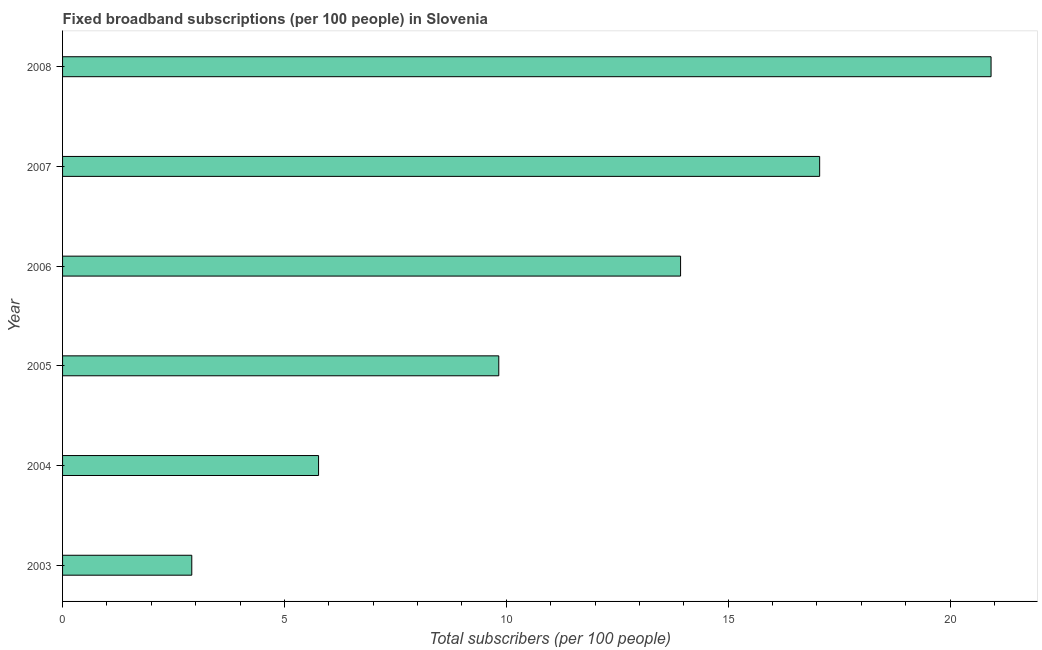Does the graph contain any zero values?
Give a very brief answer. No. Does the graph contain grids?
Provide a short and direct response. No. What is the title of the graph?
Your response must be concise. Fixed broadband subscriptions (per 100 people) in Slovenia. What is the label or title of the X-axis?
Offer a terse response. Total subscribers (per 100 people). What is the total number of fixed broadband subscriptions in 2004?
Make the answer very short. 5.77. Across all years, what is the maximum total number of fixed broadband subscriptions?
Your answer should be compact. 20.92. Across all years, what is the minimum total number of fixed broadband subscriptions?
Ensure brevity in your answer.  2.91. In which year was the total number of fixed broadband subscriptions minimum?
Your answer should be compact. 2003. What is the sum of the total number of fixed broadband subscriptions?
Give a very brief answer. 70.43. What is the difference between the total number of fixed broadband subscriptions in 2003 and 2008?
Provide a short and direct response. -18.01. What is the average total number of fixed broadband subscriptions per year?
Offer a very short reply. 11.74. What is the median total number of fixed broadband subscriptions?
Your answer should be very brief. 11.88. In how many years, is the total number of fixed broadband subscriptions greater than 6 ?
Keep it short and to the point. 4. Do a majority of the years between 2006 and 2007 (inclusive) have total number of fixed broadband subscriptions greater than 10 ?
Give a very brief answer. Yes. What is the ratio of the total number of fixed broadband subscriptions in 2004 to that in 2005?
Your response must be concise. 0.59. Is the total number of fixed broadband subscriptions in 2005 less than that in 2008?
Make the answer very short. Yes. What is the difference between the highest and the second highest total number of fixed broadband subscriptions?
Your answer should be compact. 3.86. What is the difference between the highest and the lowest total number of fixed broadband subscriptions?
Give a very brief answer. 18.01. In how many years, is the total number of fixed broadband subscriptions greater than the average total number of fixed broadband subscriptions taken over all years?
Offer a terse response. 3. How many bars are there?
Give a very brief answer. 6. How many years are there in the graph?
Your response must be concise. 6. What is the difference between two consecutive major ticks on the X-axis?
Make the answer very short. 5. What is the Total subscribers (per 100 people) of 2003?
Give a very brief answer. 2.91. What is the Total subscribers (per 100 people) in 2004?
Give a very brief answer. 5.77. What is the Total subscribers (per 100 people) of 2005?
Provide a short and direct response. 9.83. What is the Total subscribers (per 100 people) of 2006?
Give a very brief answer. 13.93. What is the Total subscribers (per 100 people) in 2007?
Your response must be concise. 17.06. What is the Total subscribers (per 100 people) in 2008?
Provide a succinct answer. 20.92. What is the difference between the Total subscribers (per 100 people) in 2003 and 2004?
Your answer should be very brief. -2.86. What is the difference between the Total subscribers (per 100 people) in 2003 and 2005?
Your response must be concise. -6.92. What is the difference between the Total subscribers (per 100 people) in 2003 and 2006?
Ensure brevity in your answer.  -11.02. What is the difference between the Total subscribers (per 100 people) in 2003 and 2007?
Offer a very short reply. -14.15. What is the difference between the Total subscribers (per 100 people) in 2003 and 2008?
Ensure brevity in your answer.  -18.01. What is the difference between the Total subscribers (per 100 people) in 2004 and 2005?
Your response must be concise. -4.06. What is the difference between the Total subscribers (per 100 people) in 2004 and 2006?
Provide a short and direct response. -8.16. What is the difference between the Total subscribers (per 100 people) in 2004 and 2007?
Offer a very short reply. -11.29. What is the difference between the Total subscribers (per 100 people) in 2004 and 2008?
Your response must be concise. -15.16. What is the difference between the Total subscribers (per 100 people) in 2005 and 2006?
Provide a short and direct response. -4.1. What is the difference between the Total subscribers (per 100 people) in 2005 and 2007?
Provide a succinct answer. -7.23. What is the difference between the Total subscribers (per 100 people) in 2005 and 2008?
Your answer should be compact. -11.09. What is the difference between the Total subscribers (per 100 people) in 2006 and 2007?
Provide a short and direct response. -3.13. What is the difference between the Total subscribers (per 100 people) in 2006 and 2008?
Your answer should be very brief. -7. What is the difference between the Total subscribers (per 100 people) in 2007 and 2008?
Your answer should be compact. -3.86. What is the ratio of the Total subscribers (per 100 people) in 2003 to that in 2004?
Your answer should be very brief. 0.51. What is the ratio of the Total subscribers (per 100 people) in 2003 to that in 2005?
Keep it short and to the point. 0.3. What is the ratio of the Total subscribers (per 100 people) in 2003 to that in 2006?
Offer a very short reply. 0.21. What is the ratio of the Total subscribers (per 100 people) in 2003 to that in 2007?
Keep it short and to the point. 0.17. What is the ratio of the Total subscribers (per 100 people) in 2003 to that in 2008?
Your answer should be very brief. 0.14. What is the ratio of the Total subscribers (per 100 people) in 2004 to that in 2005?
Offer a terse response. 0.59. What is the ratio of the Total subscribers (per 100 people) in 2004 to that in 2006?
Give a very brief answer. 0.41. What is the ratio of the Total subscribers (per 100 people) in 2004 to that in 2007?
Keep it short and to the point. 0.34. What is the ratio of the Total subscribers (per 100 people) in 2004 to that in 2008?
Ensure brevity in your answer.  0.28. What is the ratio of the Total subscribers (per 100 people) in 2005 to that in 2006?
Keep it short and to the point. 0.71. What is the ratio of the Total subscribers (per 100 people) in 2005 to that in 2007?
Your answer should be compact. 0.58. What is the ratio of the Total subscribers (per 100 people) in 2005 to that in 2008?
Offer a terse response. 0.47. What is the ratio of the Total subscribers (per 100 people) in 2006 to that in 2007?
Keep it short and to the point. 0.82. What is the ratio of the Total subscribers (per 100 people) in 2006 to that in 2008?
Provide a short and direct response. 0.67. What is the ratio of the Total subscribers (per 100 people) in 2007 to that in 2008?
Your answer should be compact. 0.81. 